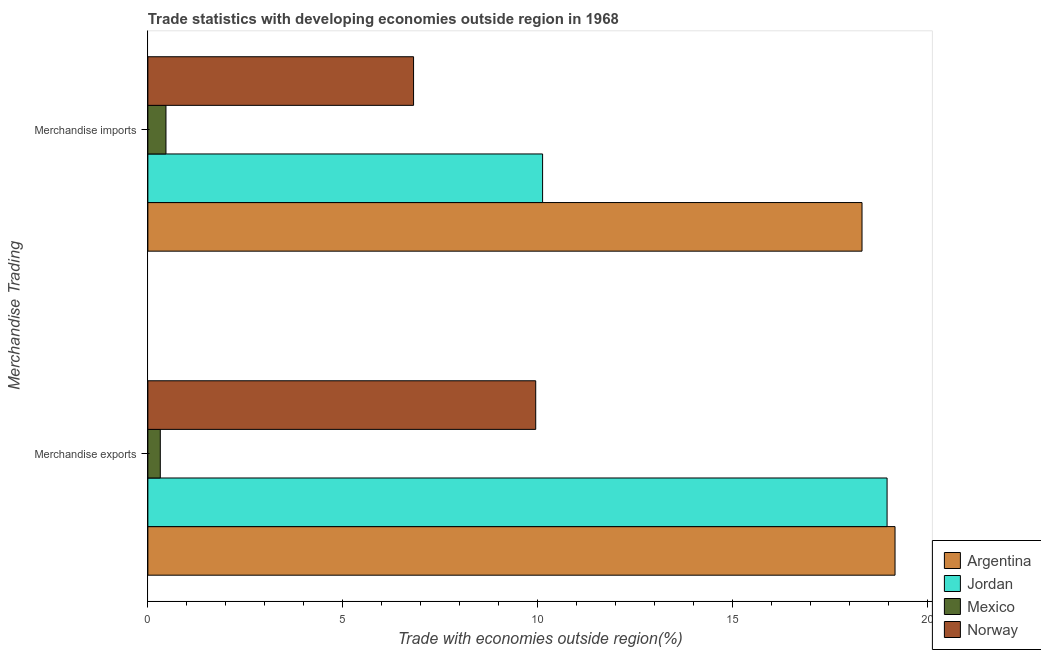Are the number of bars per tick equal to the number of legend labels?
Provide a short and direct response. Yes. Are the number of bars on each tick of the Y-axis equal?
Make the answer very short. Yes. How many bars are there on the 1st tick from the bottom?
Keep it short and to the point. 4. What is the merchandise exports in Jordan?
Make the answer very short. 18.97. Across all countries, what is the maximum merchandise imports?
Your answer should be very brief. 18.33. Across all countries, what is the minimum merchandise imports?
Provide a short and direct response. 0.46. In which country was the merchandise imports minimum?
Provide a short and direct response. Mexico. What is the total merchandise exports in the graph?
Offer a very short reply. 48.43. What is the difference between the merchandise exports in Norway and that in Argentina?
Offer a very short reply. -9.22. What is the difference between the merchandise imports in Jordan and the merchandise exports in Mexico?
Your answer should be compact. 9.81. What is the average merchandise exports per country?
Ensure brevity in your answer.  12.11. What is the difference between the merchandise exports and merchandise imports in Norway?
Ensure brevity in your answer.  3.14. What is the ratio of the merchandise imports in Argentina to that in Jordan?
Your answer should be very brief. 1.81. In how many countries, is the merchandise imports greater than the average merchandise imports taken over all countries?
Ensure brevity in your answer.  2. What does the 1st bar from the top in Merchandise imports represents?
Offer a terse response. Norway. What does the 2nd bar from the bottom in Merchandise exports represents?
Provide a short and direct response. Jordan. How many bars are there?
Ensure brevity in your answer.  8. Are all the bars in the graph horizontal?
Provide a short and direct response. Yes. How many countries are there in the graph?
Make the answer very short. 4. What is the difference between two consecutive major ticks on the X-axis?
Ensure brevity in your answer.  5. How many legend labels are there?
Offer a very short reply. 4. How are the legend labels stacked?
Provide a short and direct response. Vertical. What is the title of the graph?
Make the answer very short. Trade statistics with developing economies outside region in 1968. Does "Guyana" appear as one of the legend labels in the graph?
Your response must be concise. No. What is the label or title of the X-axis?
Offer a very short reply. Trade with economies outside region(%). What is the label or title of the Y-axis?
Make the answer very short. Merchandise Trading. What is the Trade with economies outside region(%) of Argentina in Merchandise exports?
Provide a succinct answer. 19.18. What is the Trade with economies outside region(%) of Jordan in Merchandise exports?
Keep it short and to the point. 18.97. What is the Trade with economies outside region(%) in Mexico in Merchandise exports?
Your answer should be compact. 0.32. What is the Trade with economies outside region(%) of Norway in Merchandise exports?
Offer a terse response. 9.96. What is the Trade with economies outside region(%) in Argentina in Merchandise imports?
Offer a very short reply. 18.33. What is the Trade with economies outside region(%) in Jordan in Merchandise imports?
Your answer should be compact. 10.13. What is the Trade with economies outside region(%) of Mexico in Merchandise imports?
Your answer should be very brief. 0.46. What is the Trade with economies outside region(%) of Norway in Merchandise imports?
Your response must be concise. 6.82. Across all Merchandise Trading, what is the maximum Trade with economies outside region(%) of Argentina?
Keep it short and to the point. 19.18. Across all Merchandise Trading, what is the maximum Trade with economies outside region(%) of Jordan?
Give a very brief answer. 18.97. Across all Merchandise Trading, what is the maximum Trade with economies outside region(%) of Mexico?
Keep it short and to the point. 0.46. Across all Merchandise Trading, what is the maximum Trade with economies outside region(%) in Norway?
Your answer should be compact. 9.96. Across all Merchandise Trading, what is the minimum Trade with economies outside region(%) in Argentina?
Offer a very short reply. 18.33. Across all Merchandise Trading, what is the minimum Trade with economies outside region(%) of Jordan?
Your answer should be compact. 10.13. Across all Merchandise Trading, what is the minimum Trade with economies outside region(%) in Mexico?
Provide a succinct answer. 0.32. Across all Merchandise Trading, what is the minimum Trade with economies outside region(%) in Norway?
Give a very brief answer. 6.82. What is the total Trade with economies outside region(%) of Argentina in the graph?
Keep it short and to the point. 37.51. What is the total Trade with economies outside region(%) of Jordan in the graph?
Offer a very short reply. 29.11. What is the total Trade with economies outside region(%) in Mexico in the graph?
Provide a short and direct response. 0.78. What is the total Trade with economies outside region(%) of Norway in the graph?
Make the answer very short. 16.78. What is the difference between the Trade with economies outside region(%) in Argentina in Merchandise exports and that in Merchandise imports?
Your answer should be very brief. 0.85. What is the difference between the Trade with economies outside region(%) in Jordan in Merchandise exports and that in Merchandise imports?
Offer a very short reply. 8.84. What is the difference between the Trade with economies outside region(%) in Mexico in Merchandise exports and that in Merchandise imports?
Keep it short and to the point. -0.15. What is the difference between the Trade with economies outside region(%) in Norway in Merchandise exports and that in Merchandise imports?
Your response must be concise. 3.14. What is the difference between the Trade with economies outside region(%) of Argentina in Merchandise exports and the Trade with economies outside region(%) of Jordan in Merchandise imports?
Provide a short and direct response. 9.05. What is the difference between the Trade with economies outside region(%) of Argentina in Merchandise exports and the Trade with economies outside region(%) of Mexico in Merchandise imports?
Your answer should be very brief. 18.71. What is the difference between the Trade with economies outside region(%) in Argentina in Merchandise exports and the Trade with economies outside region(%) in Norway in Merchandise imports?
Your response must be concise. 12.36. What is the difference between the Trade with economies outside region(%) of Jordan in Merchandise exports and the Trade with economies outside region(%) of Mexico in Merchandise imports?
Ensure brevity in your answer.  18.51. What is the difference between the Trade with economies outside region(%) in Jordan in Merchandise exports and the Trade with economies outside region(%) in Norway in Merchandise imports?
Offer a very short reply. 12.15. What is the difference between the Trade with economies outside region(%) of Mexico in Merchandise exports and the Trade with economies outside region(%) of Norway in Merchandise imports?
Make the answer very short. -6.5. What is the average Trade with economies outside region(%) of Argentina per Merchandise Trading?
Make the answer very short. 18.75. What is the average Trade with economies outside region(%) in Jordan per Merchandise Trading?
Provide a succinct answer. 14.55. What is the average Trade with economies outside region(%) in Mexico per Merchandise Trading?
Provide a short and direct response. 0.39. What is the average Trade with economies outside region(%) in Norway per Merchandise Trading?
Give a very brief answer. 8.39. What is the difference between the Trade with economies outside region(%) in Argentina and Trade with economies outside region(%) in Jordan in Merchandise exports?
Give a very brief answer. 0.2. What is the difference between the Trade with economies outside region(%) of Argentina and Trade with economies outside region(%) of Mexico in Merchandise exports?
Your answer should be very brief. 18.86. What is the difference between the Trade with economies outside region(%) in Argentina and Trade with economies outside region(%) in Norway in Merchandise exports?
Your response must be concise. 9.22. What is the difference between the Trade with economies outside region(%) of Jordan and Trade with economies outside region(%) of Mexico in Merchandise exports?
Ensure brevity in your answer.  18.66. What is the difference between the Trade with economies outside region(%) of Jordan and Trade with economies outside region(%) of Norway in Merchandise exports?
Provide a succinct answer. 9.02. What is the difference between the Trade with economies outside region(%) of Mexico and Trade with economies outside region(%) of Norway in Merchandise exports?
Your answer should be very brief. -9.64. What is the difference between the Trade with economies outside region(%) of Argentina and Trade with economies outside region(%) of Jordan in Merchandise imports?
Give a very brief answer. 8.2. What is the difference between the Trade with economies outside region(%) of Argentina and Trade with economies outside region(%) of Mexico in Merchandise imports?
Your answer should be very brief. 17.87. What is the difference between the Trade with economies outside region(%) of Argentina and Trade with economies outside region(%) of Norway in Merchandise imports?
Ensure brevity in your answer.  11.51. What is the difference between the Trade with economies outside region(%) of Jordan and Trade with economies outside region(%) of Mexico in Merchandise imports?
Make the answer very short. 9.67. What is the difference between the Trade with economies outside region(%) of Jordan and Trade with economies outside region(%) of Norway in Merchandise imports?
Your answer should be very brief. 3.31. What is the difference between the Trade with economies outside region(%) in Mexico and Trade with economies outside region(%) in Norway in Merchandise imports?
Provide a short and direct response. -6.36. What is the ratio of the Trade with economies outside region(%) of Argentina in Merchandise exports to that in Merchandise imports?
Your answer should be compact. 1.05. What is the ratio of the Trade with economies outside region(%) of Jordan in Merchandise exports to that in Merchandise imports?
Offer a terse response. 1.87. What is the ratio of the Trade with economies outside region(%) in Mexico in Merchandise exports to that in Merchandise imports?
Keep it short and to the point. 0.69. What is the ratio of the Trade with economies outside region(%) in Norway in Merchandise exports to that in Merchandise imports?
Ensure brevity in your answer.  1.46. What is the difference between the highest and the second highest Trade with economies outside region(%) in Argentina?
Offer a very short reply. 0.85. What is the difference between the highest and the second highest Trade with economies outside region(%) in Jordan?
Give a very brief answer. 8.84. What is the difference between the highest and the second highest Trade with economies outside region(%) in Mexico?
Give a very brief answer. 0.15. What is the difference between the highest and the second highest Trade with economies outside region(%) in Norway?
Keep it short and to the point. 3.14. What is the difference between the highest and the lowest Trade with economies outside region(%) in Argentina?
Give a very brief answer. 0.85. What is the difference between the highest and the lowest Trade with economies outside region(%) of Jordan?
Make the answer very short. 8.84. What is the difference between the highest and the lowest Trade with economies outside region(%) in Mexico?
Your response must be concise. 0.15. What is the difference between the highest and the lowest Trade with economies outside region(%) of Norway?
Your answer should be very brief. 3.14. 